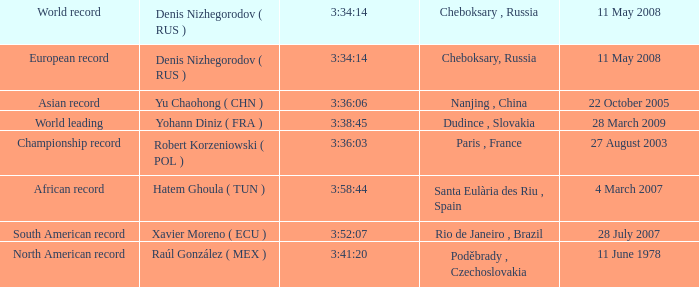When 3:38:45 is  3:34:14 what is the date on May 11th, 2008? 28 March 2009. 